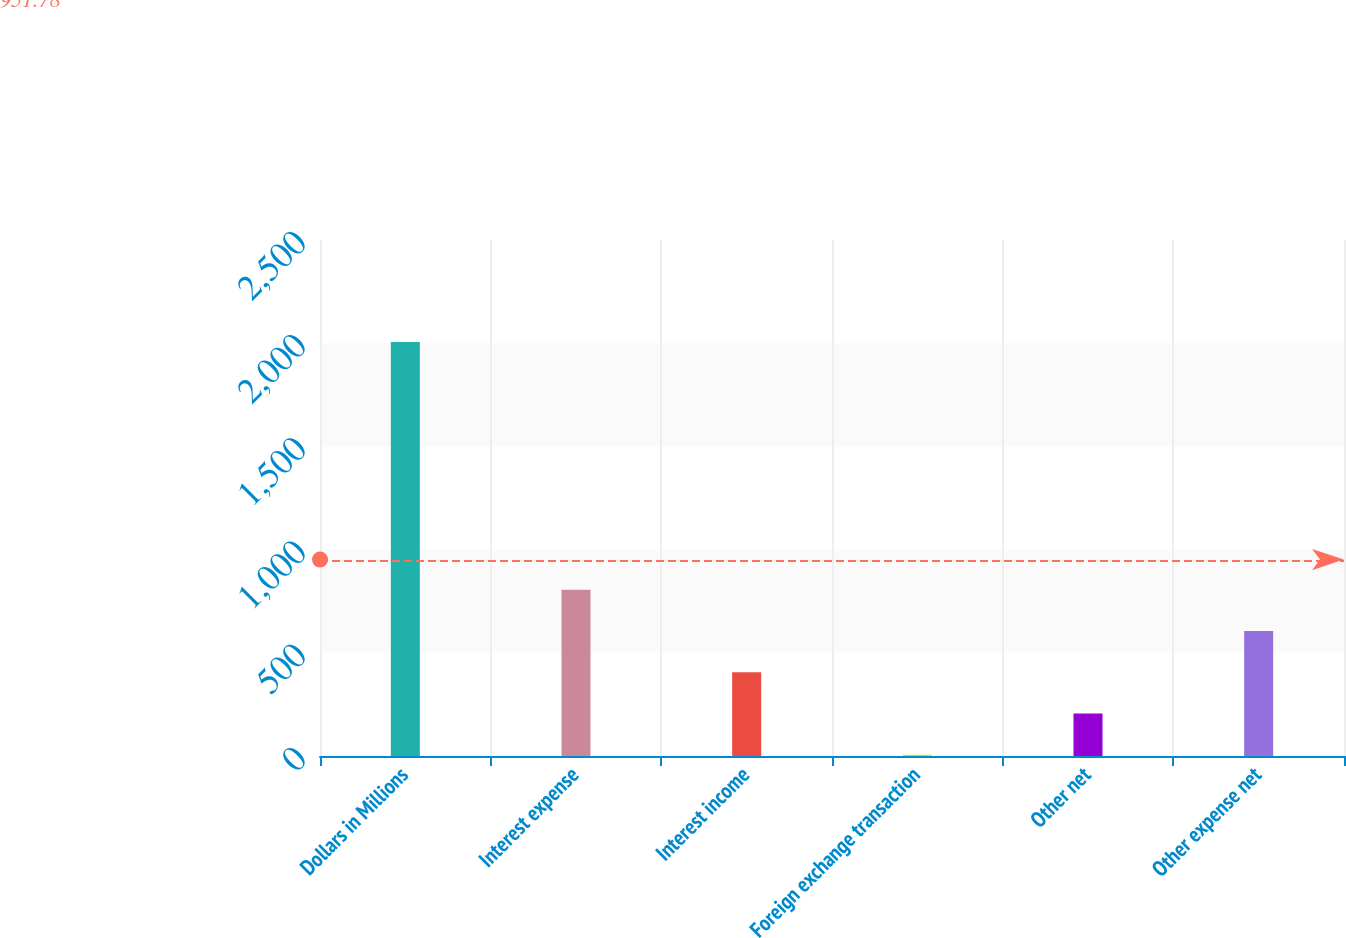<chart> <loc_0><loc_0><loc_500><loc_500><bar_chart><fcel>Dollars in Millions<fcel>Interest expense<fcel>Interest income<fcel>Foreign exchange transaction<fcel>Other net<fcel>Other expense net<nl><fcel>2006<fcel>806<fcel>406<fcel>6<fcel>206<fcel>606<nl></chart> 